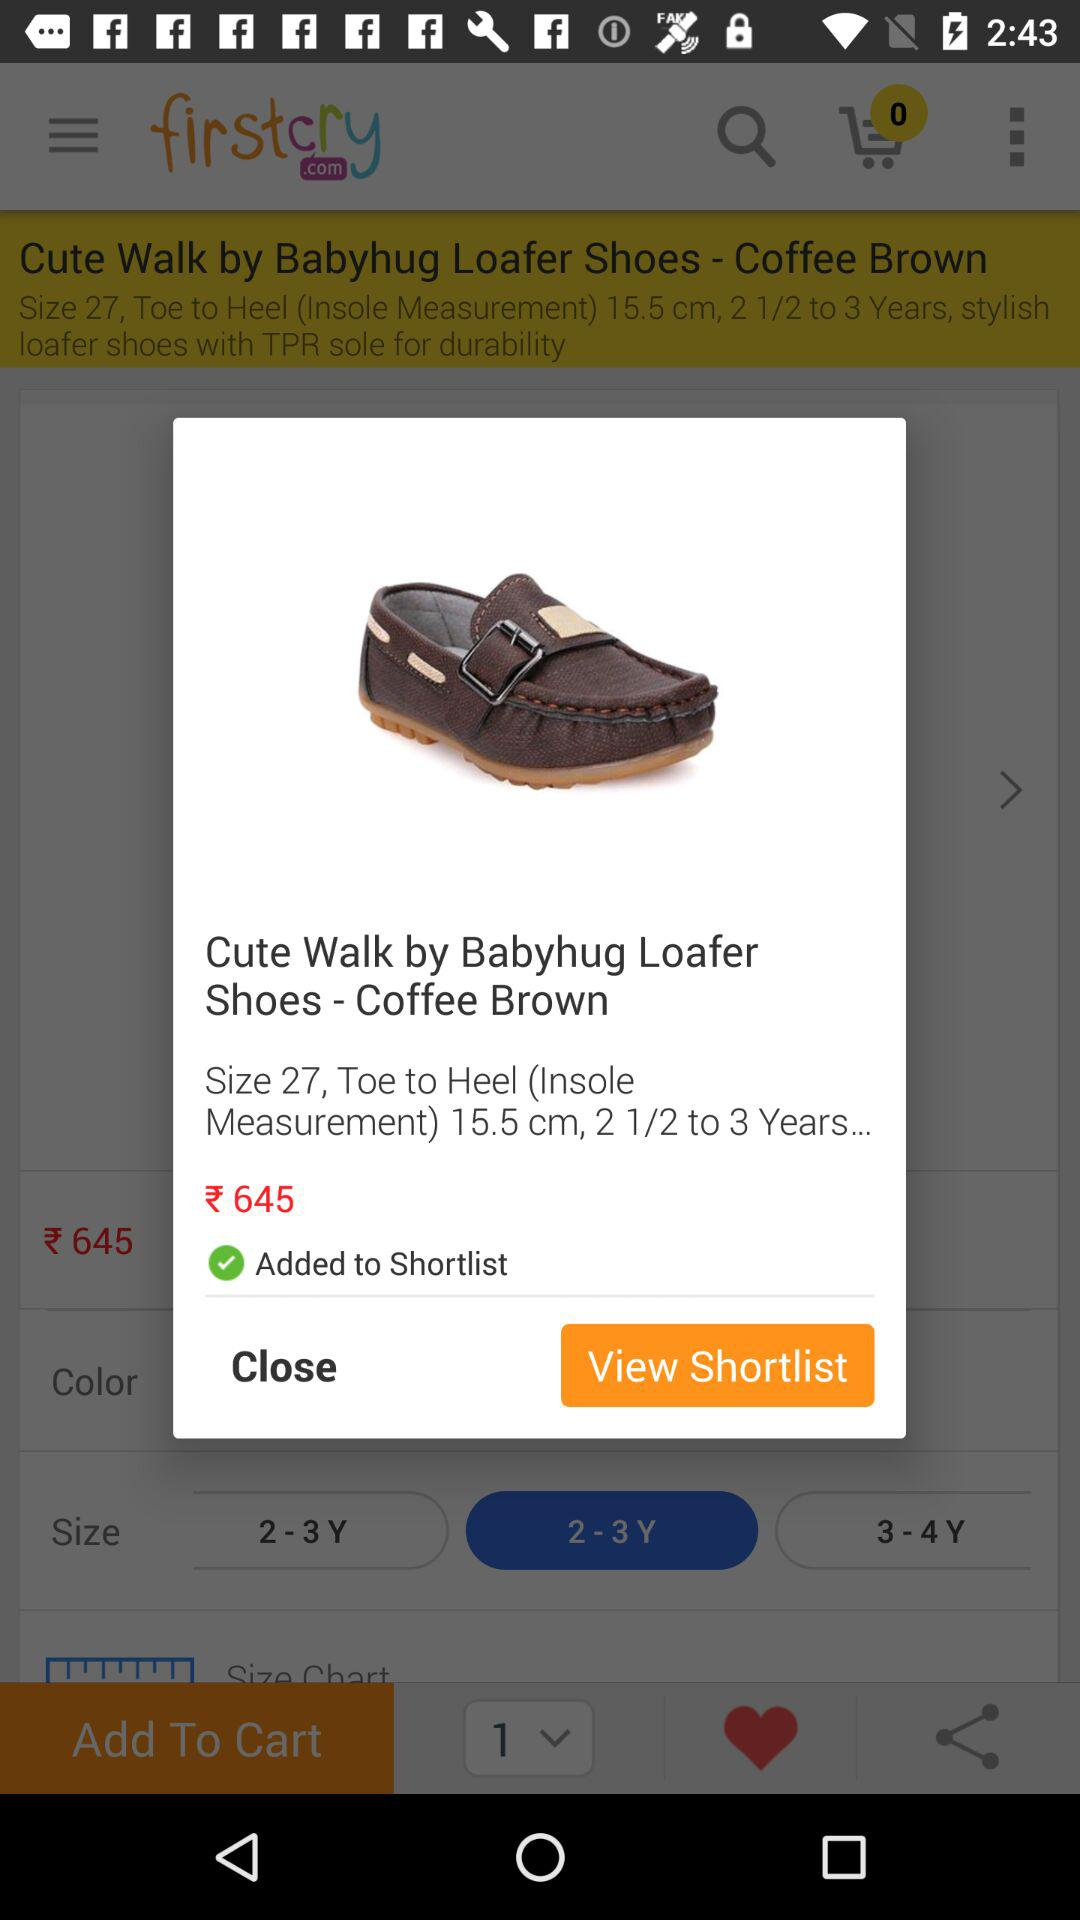What is the name of the shoes? The name of the shoes is "Cute Walk by Babyhug Loafer Shoes". 